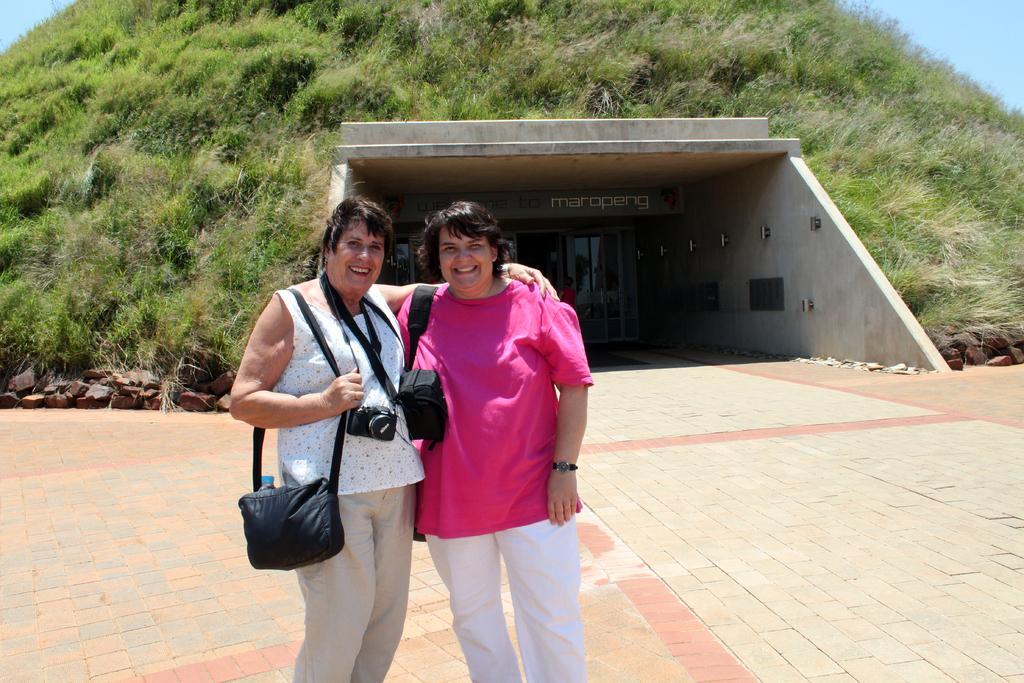Please provide a concise description of this image. There are two women standing in this picture. One of the woman is holding a camera in her neck. In the background there is a hill and some trees on the hill. We can observe a building here. 